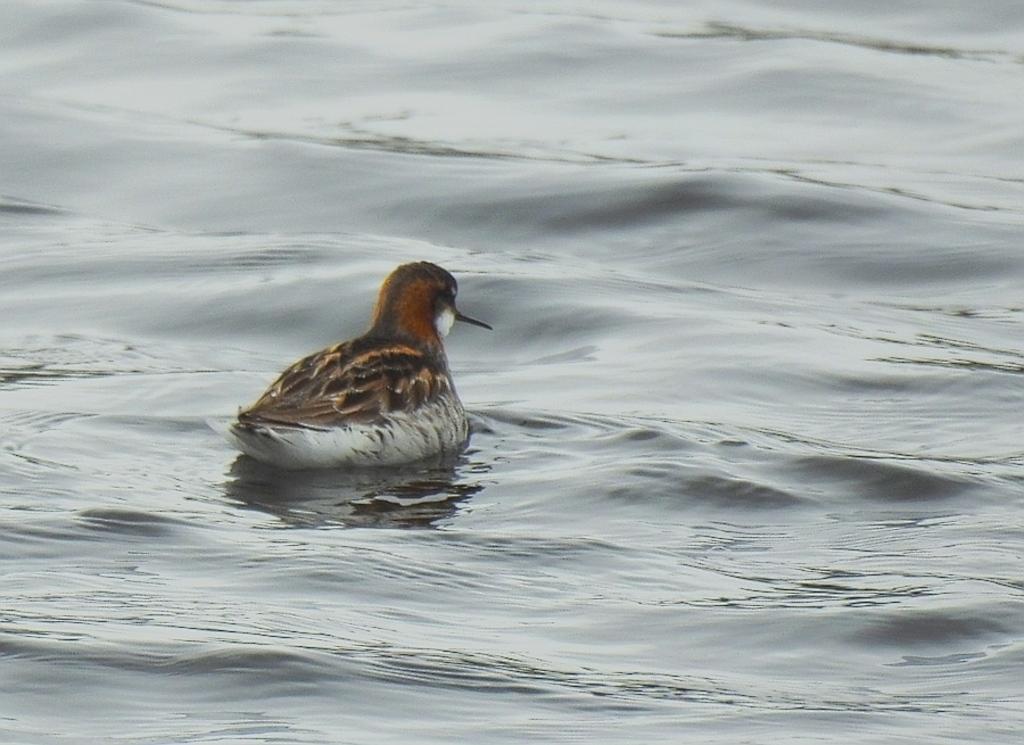Could you give a brief overview of what you see in this image? In this image I can see the bird in the water. I can see the bird is in brown, black and white color. 